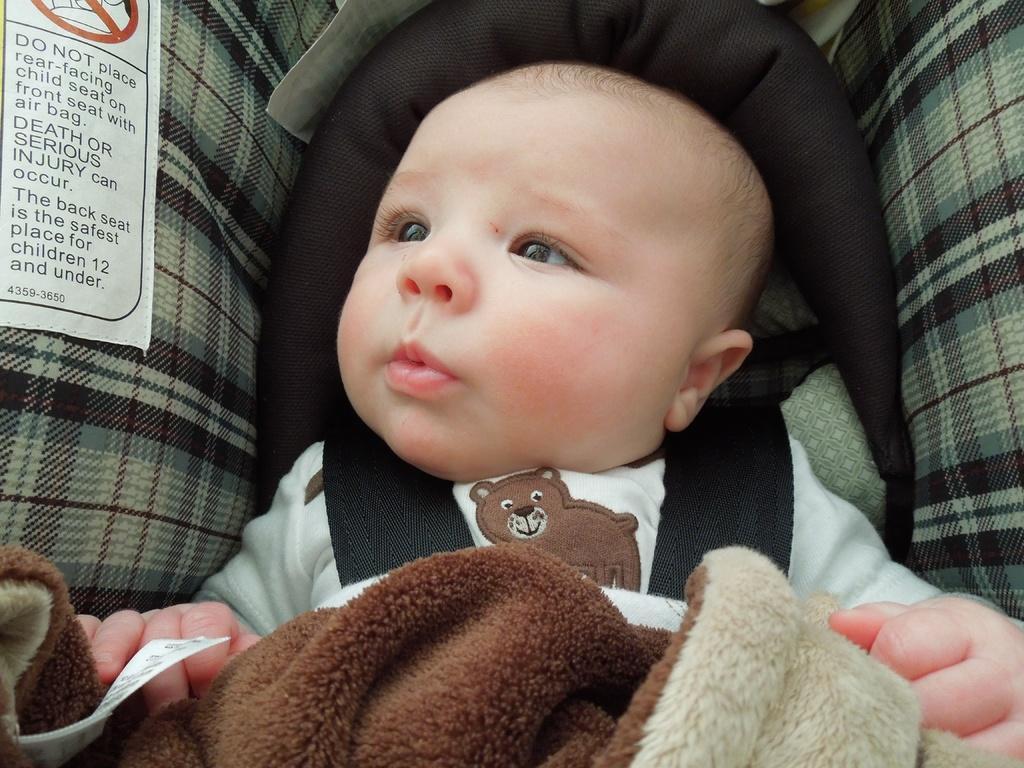Can you describe this image briefly? In this picture I can see there is a infant sitting here and wearing a white shirt and there is a brown color blanket here and the baby is looking on to left and there is a sticker here and it has some precautions. 